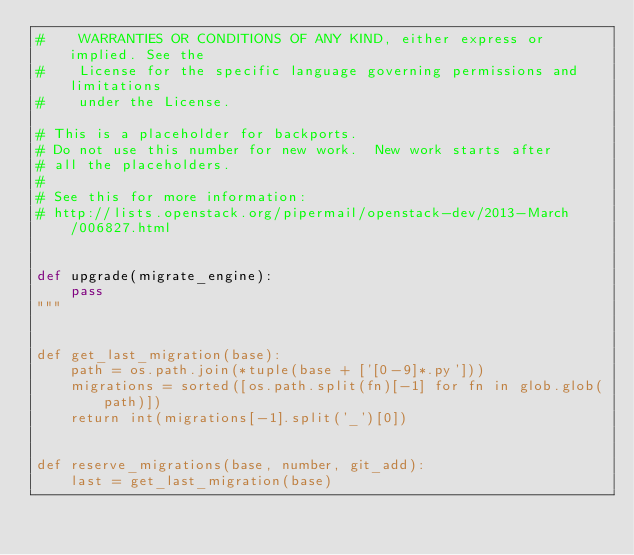<code> <loc_0><loc_0><loc_500><loc_500><_Python_>#    WARRANTIES OR CONDITIONS OF ANY KIND, either express or implied. See the
#    License for the specific language governing permissions and limitations
#    under the License.

# This is a placeholder for backports.
# Do not use this number for new work.  New work starts after
# all the placeholders.
#
# See this for more information:
# http://lists.openstack.org/pipermail/openstack-dev/2013-March/006827.html


def upgrade(migrate_engine):
    pass
"""


def get_last_migration(base):
    path = os.path.join(*tuple(base + ['[0-9]*.py']))
    migrations = sorted([os.path.split(fn)[-1] for fn in glob.glob(path)])
    return int(migrations[-1].split('_')[0])


def reserve_migrations(base, number, git_add):
    last = get_last_migration(base)</code> 